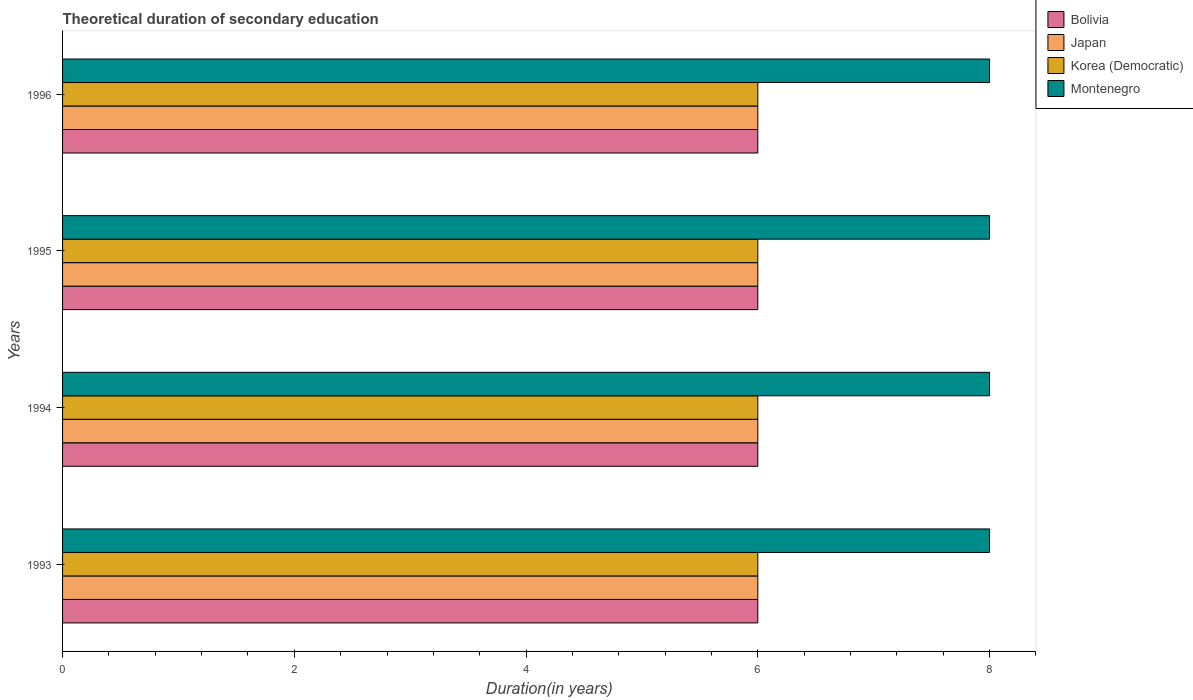How many groups of bars are there?
Provide a succinct answer. 4. Are the number of bars per tick equal to the number of legend labels?
Your answer should be compact. Yes. Are the number of bars on each tick of the Y-axis equal?
Your answer should be compact. Yes. Across all years, what is the maximum total theoretical duration of secondary education in Japan?
Your answer should be very brief. 6. In which year was the total theoretical duration of secondary education in Montenegro minimum?
Provide a short and direct response. 1993. What is the total total theoretical duration of secondary education in Bolivia in the graph?
Ensure brevity in your answer.  24. What is the difference between the total theoretical duration of secondary education in Montenegro in 1993 and the total theoretical duration of secondary education in Japan in 1995?
Offer a terse response. 2. In the year 1994, what is the difference between the total theoretical duration of secondary education in Montenegro and total theoretical duration of secondary education in Korea (Democratic)?
Provide a succinct answer. 2. In how many years, is the total theoretical duration of secondary education in Bolivia greater than 5.2 years?
Keep it short and to the point. 4. Is the total theoretical duration of secondary education in Bolivia in 1994 less than that in 1995?
Ensure brevity in your answer.  No. Is the difference between the total theoretical duration of secondary education in Montenegro in 1993 and 1995 greater than the difference between the total theoretical duration of secondary education in Korea (Democratic) in 1993 and 1995?
Your answer should be very brief. No. What is the difference between the highest and the second highest total theoretical duration of secondary education in Japan?
Offer a very short reply. 0. In how many years, is the total theoretical duration of secondary education in Montenegro greater than the average total theoretical duration of secondary education in Montenegro taken over all years?
Your answer should be very brief. 0. Is the sum of the total theoretical duration of secondary education in Bolivia in 1993 and 1995 greater than the maximum total theoretical duration of secondary education in Japan across all years?
Your answer should be compact. Yes. What does the 3rd bar from the top in 1996 represents?
Ensure brevity in your answer.  Japan. What does the 3rd bar from the bottom in 1993 represents?
Give a very brief answer. Korea (Democratic). Is it the case that in every year, the sum of the total theoretical duration of secondary education in Japan and total theoretical duration of secondary education in Korea (Democratic) is greater than the total theoretical duration of secondary education in Montenegro?
Ensure brevity in your answer.  Yes. How many bars are there?
Ensure brevity in your answer.  16. Are all the bars in the graph horizontal?
Your response must be concise. Yes. How many years are there in the graph?
Your answer should be very brief. 4. What is the difference between two consecutive major ticks on the X-axis?
Keep it short and to the point. 2. Are the values on the major ticks of X-axis written in scientific E-notation?
Your answer should be compact. No. Does the graph contain grids?
Keep it short and to the point. No. How many legend labels are there?
Keep it short and to the point. 4. What is the title of the graph?
Provide a short and direct response. Theoretical duration of secondary education. What is the label or title of the X-axis?
Ensure brevity in your answer.  Duration(in years). What is the label or title of the Y-axis?
Provide a succinct answer. Years. What is the Duration(in years) of Bolivia in 1993?
Your answer should be compact. 6. What is the Duration(in years) in Japan in 1993?
Provide a short and direct response. 6. What is the Duration(in years) in Korea (Democratic) in 1993?
Your answer should be compact. 6. What is the Duration(in years) of Montenegro in 1993?
Keep it short and to the point. 8. What is the Duration(in years) of Bolivia in 1994?
Provide a succinct answer. 6. What is the Duration(in years) in Montenegro in 1994?
Ensure brevity in your answer.  8. What is the Duration(in years) in Bolivia in 1995?
Your answer should be very brief. 6. What is the Duration(in years) of Japan in 1995?
Offer a terse response. 6. What is the Duration(in years) in Korea (Democratic) in 1995?
Offer a very short reply. 6. What is the Duration(in years) of Bolivia in 1996?
Ensure brevity in your answer.  6. What is the Duration(in years) in Korea (Democratic) in 1996?
Offer a terse response. 6. Across all years, what is the maximum Duration(in years) in Bolivia?
Ensure brevity in your answer.  6. Across all years, what is the maximum Duration(in years) in Japan?
Offer a very short reply. 6. Across all years, what is the minimum Duration(in years) in Bolivia?
Your answer should be very brief. 6. What is the total Duration(in years) in Japan in the graph?
Ensure brevity in your answer.  24. What is the total Duration(in years) of Korea (Democratic) in the graph?
Ensure brevity in your answer.  24. What is the total Duration(in years) of Montenegro in the graph?
Your answer should be very brief. 32. What is the difference between the Duration(in years) in Japan in 1993 and that in 1994?
Provide a short and direct response. 0. What is the difference between the Duration(in years) in Korea (Democratic) in 1993 and that in 1994?
Make the answer very short. 0. What is the difference between the Duration(in years) in Japan in 1993 and that in 1995?
Provide a short and direct response. 0. What is the difference between the Duration(in years) of Montenegro in 1993 and that in 1995?
Offer a terse response. 0. What is the difference between the Duration(in years) of Korea (Democratic) in 1993 and that in 1996?
Provide a short and direct response. 0. What is the difference between the Duration(in years) of Montenegro in 1993 and that in 1996?
Make the answer very short. 0. What is the difference between the Duration(in years) in Montenegro in 1994 and that in 1995?
Give a very brief answer. 0. What is the difference between the Duration(in years) in Bolivia in 1994 and that in 1996?
Your response must be concise. 0. What is the difference between the Duration(in years) of Korea (Democratic) in 1994 and that in 1996?
Offer a very short reply. 0. What is the difference between the Duration(in years) of Montenegro in 1994 and that in 1996?
Give a very brief answer. 0. What is the difference between the Duration(in years) in Bolivia in 1995 and that in 1996?
Your answer should be compact. 0. What is the difference between the Duration(in years) in Japan in 1995 and that in 1996?
Offer a very short reply. 0. What is the difference between the Duration(in years) of Korea (Democratic) in 1995 and that in 1996?
Provide a succinct answer. 0. What is the difference between the Duration(in years) in Montenegro in 1995 and that in 1996?
Your response must be concise. 0. What is the difference between the Duration(in years) in Bolivia in 1993 and the Duration(in years) in Montenegro in 1994?
Offer a very short reply. -2. What is the difference between the Duration(in years) in Japan in 1993 and the Duration(in years) in Montenegro in 1994?
Your answer should be compact. -2. What is the difference between the Duration(in years) of Bolivia in 1993 and the Duration(in years) of Montenegro in 1995?
Provide a succinct answer. -2. What is the difference between the Duration(in years) of Japan in 1993 and the Duration(in years) of Korea (Democratic) in 1995?
Your answer should be compact. 0. What is the difference between the Duration(in years) of Japan in 1993 and the Duration(in years) of Montenegro in 1995?
Keep it short and to the point. -2. What is the difference between the Duration(in years) in Bolivia in 1993 and the Duration(in years) in Montenegro in 1996?
Provide a succinct answer. -2. What is the difference between the Duration(in years) of Japan in 1993 and the Duration(in years) of Korea (Democratic) in 1996?
Offer a terse response. 0. What is the difference between the Duration(in years) of Korea (Democratic) in 1993 and the Duration(in years) of Montenegro in 1996?
Provide a succinct answer. -2. What is the difference between the Duration(in years) in Japan in 1994 and the Duration(in years) in Montenegro in 1995?
Make the answer very short. -2. What is the difference between the Duration(in years) of Korea (Democratic) in 1994 and the Duration(in years) of Montenegro in 1995?
Your answer should be very brief. -2. What is the difference between the Duration(in years) of Bolivia in 1994 and the Duration(in years) of Japan in 1996?
Offer a terse response. 0. What is the difference between the Duration(in years) of Bolivia in 1994 and the Duration(in years) of Korea (Democratic) in 1996?
Provide a short and direct response. 0. What is the difference between the Duration(in years) in Japan in 1994 and the Duration(in years) in Korea (Democratic) in 1996?
Ensure brevity in your answer.  0. What is the difference between the Duration(in years) in Bolivia in 1995 and the Duration(in years) in Montenegro in 1996?
Keep it short and to the point. -2. What is the difference between the Duration(in years) of Japan in 1995 and the Duration(in years) of Korea (Democratic) in 1996?
Provide a succinct answer. 0. What is the average Duration(in years) of Bolivia per year?
Offer a terse response. 6. In the year 1993, what is the difference between the Duration(in years) in Bolivia and Duration(in years) in Korea (Democratic)?
Your answer should be compact. 0. In the year 1993, what is the difference between the Duration(in years) of Bolivia and Duration(in years) of Montenegro?
Ensure brevity in your answer.  -2. In the year 1993, what is the difference between the Duration(in years) in Japan and Duration(in years) in Korea (Democratic)?
Your response must be concise. 0. In the year 1994, what is the difference between the Duration(in years) in Bolivia and Duration(in years) in Japan?
Offer a terse response. 0. In the year 1994, what is the difference between the Duration(in years) in Bolivia and Duration(in years) in Korea (Democratic)?
Offer a terse response. 0. In the year 1994, what is the difference between the Duration(in years) of Japan and Duration(in years) of Montenegro?
Keep it short and to the point. -2. In the year 1995, what is the difference between the Duration(in years) of Japan and Duration(in years) of Korea (Democratic)?
Keep it short and to the point. 0. What is the ratio of the Duration(in years) in Korea (Democratic) in 1993 to that in 1994?
Your response must be concise. 1. What is the ratio of the Duration(in years) of Bolivia in 1993 to that in 1995?
Provide a short and direct response. 1. What is the ratio of the Duration(in years) in Korea (Democratic) in 1993 to that in 1995?
Ensure brevity in your answer.  1. What is the ratio of the Duration(in years) in Montenegro in 1993 to that in 1995?
Offer a terse response. 1. What is the ratio of the Duration(in years) in Japan in 1994 to that in 1995?
Offer a terse response. 1. What is the ratio of the Duration(in years) in Korea (Democratic) in 1994 to that in 1995?
Provide a short and direct response. 1. What is the ratio of the Duration(in years) of Korea (Democratic) in 1994 to that in 1996?
Ensure brevity in your answer.  1. What is the ratio of the Duration(in years) in Montenegro in 1994 to that in 1996?
Offer a very short reply. 1. What is the difference between the highest and the lowest Duration(in years) in Bolivia?
Your answer should be very brief. 0. What is the difference between the highest and the lowest Duration(in years) in Japan?
Provide a short and direct response. 0. What is the difference between the highest and the lowest Duration(in years) in Korea (Democratic)?
Make the answer very short. 0. 